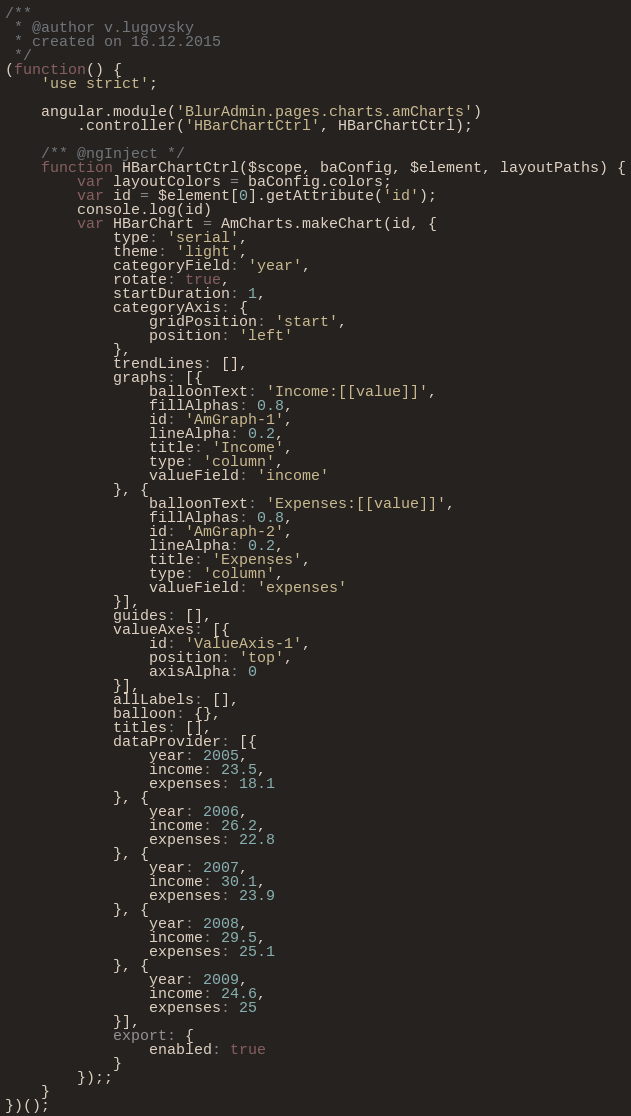Convert code to text. <code><loc_0><loc_0><loc_500><loc_500><_JavaScript_>/**
 * @author v.lugovsky
 * created on 16.12.2015
 */
(function() {
    'use strict';

    angular.module('BlurAdmin.pages.charts.amCharts')
        .controller('HBarChartCtrl', HBarChartCtrl);

    /** @ngInject */
    function HBarChartCtrl($scope, baConfig, $element, layoutPaths) {
        var layoutColors = baConfig.colors;
        var id = $element[0].getAttribute('id');
        console.log(id)
        var HBarChart = AmCharts.makeChart(id, {
            type: 'serial',
            theme: 'light',
            categoryField: 'year',
            rotate: true,
            startDuration: 1,
            categoryAxis: {
                gridPosition: 'start',
                position: 'left'
            },
            trendLines: [],
            graphs: [{
                balloonText: 'Income:[[value]]',
                fillAlphas: 0.8,
                id: 'AmGraph-1',
                lineAlpha: 0.2,
                title: 'Income',
                type: 'column',
                valueField: 'income'
            }, {
                balloonText: 'Expenses:[[value]]',
                fillAlphas: 0.8,
                id: 'AmGraph-2',
                lineAlpha: 0.2,
                title: 'Expenses',
                type: 'column',
                valueField: 'expenses'
            }],
            guides: [],
            valueAxes: [{
                id: 'ValueAxis-1',
                position: 'top',
                axisAlpha: 0
            }],
            allLabels: [],
            balloon: {},
            titles: [],
            dataProvider: [{
                year: 2005,
                income: 23.5,
                expenses: 18.1
            }, {
                year: 2006,
                income: 26.2,
                expenses: 22.8
            }, {
                year: 2007,
                income: 30.1,
                expenses: 23.9
            }, {
                year: 2008,
                income: 29.5,
                expenses: 25.1
            }, {
                year: 2009,
                income: 24.6,
                expenses: 25
            }],
            export: {
                enabled: true
            }
        });;
    }
})();</code> 